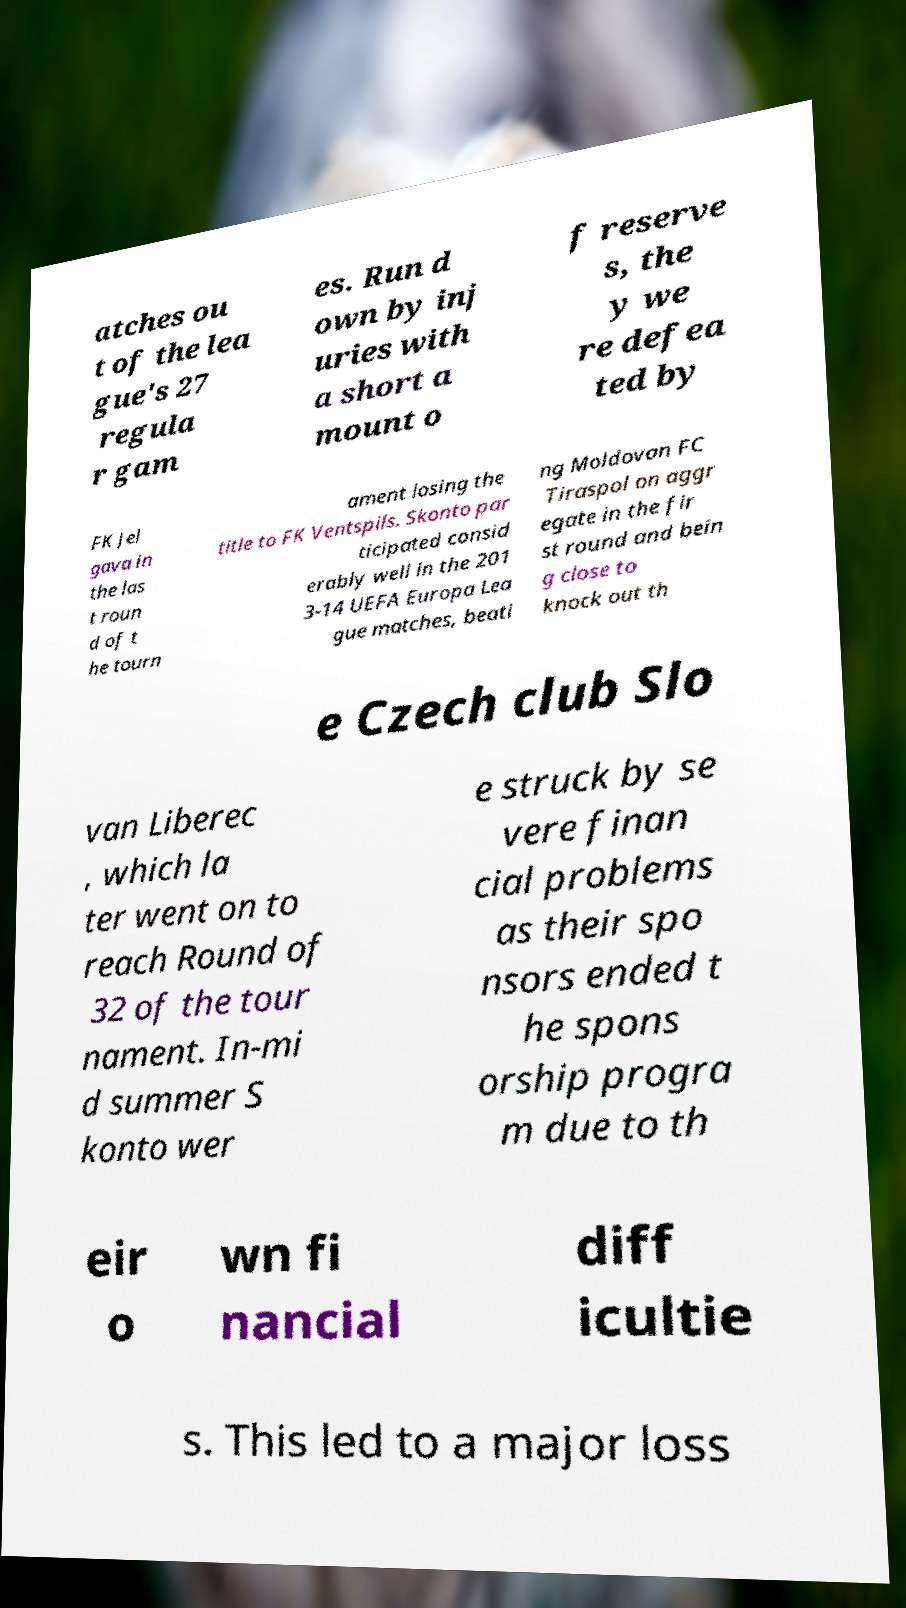Can you read and provide the text displayed in the image?This photo seems to have some interesting text. Can you extract and type it out for me? atches ou t of the lea gue's 27 regula r gam es. Run d own by inj uries with a short a mount o f reserve s, the y we re defea ted by FK Jel gava in the las t roun d of t he tourn ament losing the title to FK Ventspils. Skonto par ticipated consid erably well in the 201 3-14 UEFA Europa Lea gue matches, beati ng Moldovan FC Tiraspol on aggr egate in the fir st round and bein g close to knock out th e Czech club Slo van Liberec , which la ter went on to reach Round of 32 of the tour nament. In-mi d summer S konto wer e struck by se vere finan cial problems as their spo nsors ended t he spons orship progra m due to th eir o wn fi nancial diff icultie s. This led to a major loss 